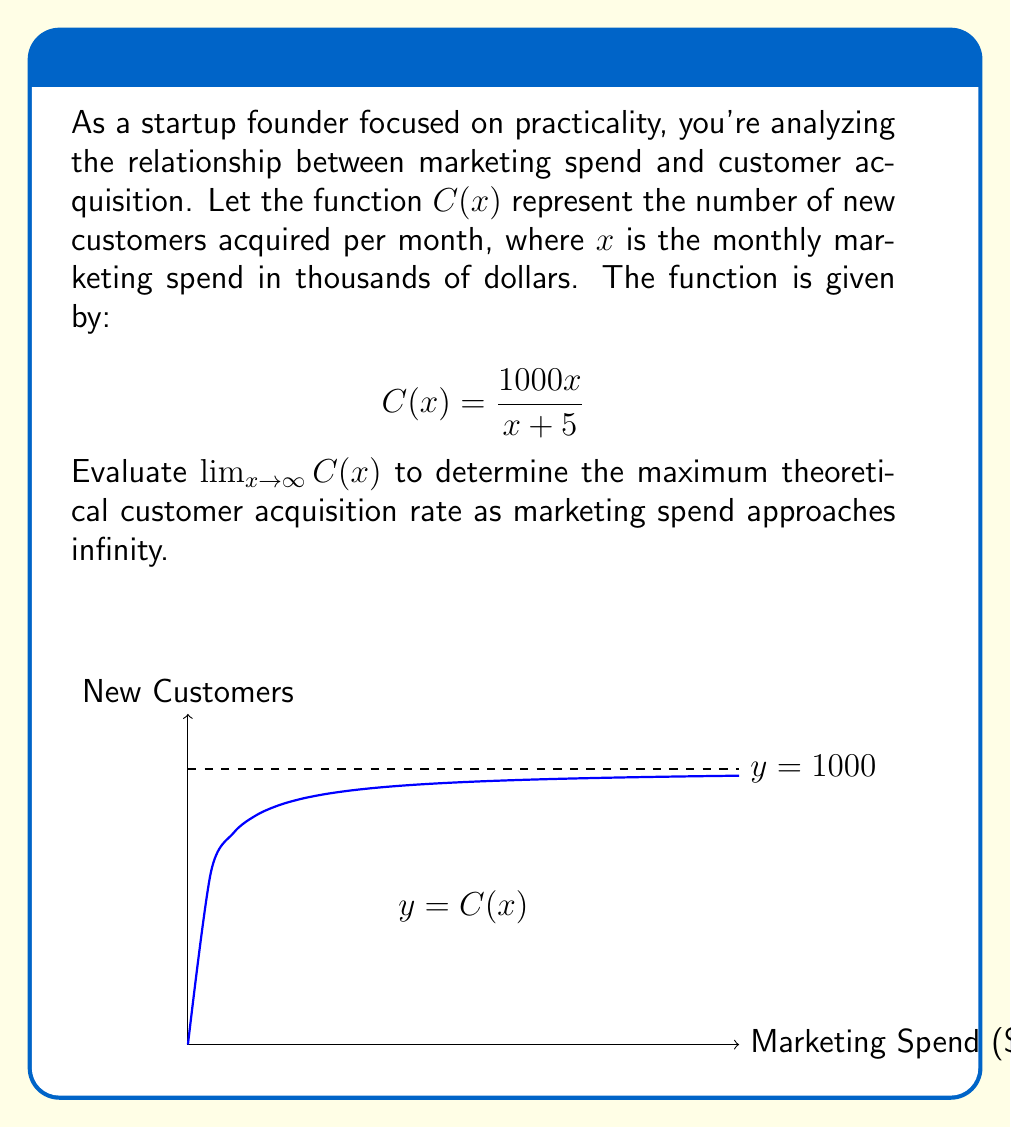What is the answer to this math problem? Let's approach this step-by-step:

1) We need to evaluate $\lim_{x \to \infty} C(x)$ where $C(x) = \frac{1000x}{x + 5}$.

2) As $x$ approaches infinity, both the numerator and denominator grow without bound. This is an indeterminate form of type $\frac{\infty}{\infty}$.

3) To resolve this, we can divide both the numerator and denominator by the highest power of $x$ in the denominator, which is $x$:

   $$\lim_{x \to \infty} C(x) = \lim_{x \to \infty} \frac{1000x}{x + 5} = \lim_{x \to \infty} \frac{1000x/x}{(x + 5)/x} = \lim_{x \to \infty} \frac{1000}{1 + 5/x}$$

4) As $x$ approaches infinity, $5/x$ approaches 0:

   $$\lim_{x \to \infty} \frac{1000}{1 + 5/x} = \frac{1000}{1 + 0} = 1000$$

5) This result indicates that no matter how much the marketing spend increases, the customer acquisition rate will never exceed 1000 new customers per month.

From a business perspective, this suggests that there's a theoretical maximum to customer acquisition that can't be surpassed simply by increasing marketing spend. This aligns with the practical mindset of a startup founder, indicating that beyond a certain point, increasing marketing budget may not yield proportional returns.
Answer: $\lim_{x \to \infty} C(x) = 1000$ 